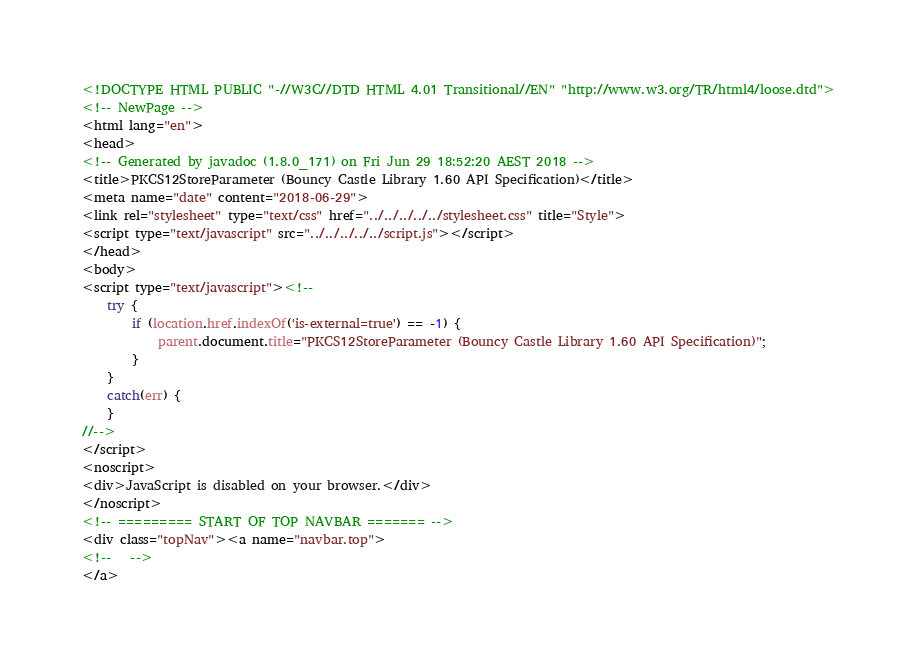Convert code to text. <code><loc_0><loc_0><loc_500><loc_500><_HTML_><!DOCTYPE HTML PUBLIC "-//W3C//DTD HTML 4.01 Transitional//EN" "http://www.w3.org/TR/html4/loose.dtd">
<!-- NewPage -->
<html lang="en">
<head>
<!-- Generated by javadoc (1.8.0_171) on Fri Jun 29 18:52:20 AEST 2018 -->
<title>PKCS12StoreParameter (Bouncy Castle Library 1.60 API Specification)</title>
<meta name="date" content="2018-06-29">
<link rel="stylesheet" type="text/css" href="../../../../../stylesheet.css" title="Style">
<script type="text/javascript" src="../../../../../script.js"></script>
</head>
<body>
<script type="text/javascript"><!--
    try {
        if (location.href.indexOf('is-external=true') == -1) {
            parent.document.title="PKCS12StoreParameter (Bouncy Castle Library 1.60 API Specification)";
        }
    }
    catch(err) {
    }
//-->
</script>
<noscript>
<div>JavaScript is disabled on your browser.</div>
</noscript>
<!-- ========= START OF TOP NAVBAR ======= -->
<div class="topNav"><a name="navbar.top">
<!--   -->
</a></code> 